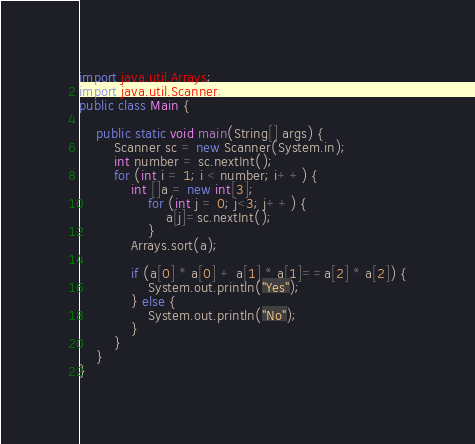Convert code to text. <code><loc_0><loc_0><loc_500><loc_500><_Java_>import java.util.Arrays;
import java.util.Scanner;
public class Main {

    public static void main(String[] args) {
        Scanner sc = new Scanner(System.in);
        int number = sc.nextInt();
        for (int i = 1; i < number; i++) {
            int []a = new int[3];
                for (int j = 0; j<3; j++) {
                    a[j]=sc.nextInt();
                }
            Arrays.sort(a);

            if (a[0] * a[0] + a[1] * a[1]==a[2] * a[2]) {
                System.out.println("Yes");
            } else {
                System.out.println("No");
            }
        }
    }
}</code> 